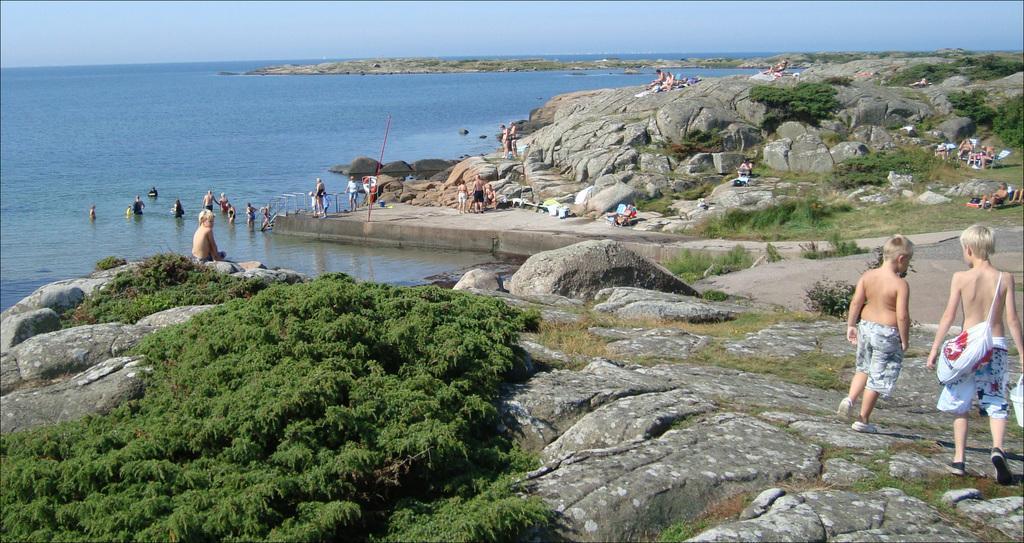Could you give a brief overview of what you see in this image? In this image we can see people and there are rocks. On the left there is a river. On the right there are chaise lounges. In the background there is sky. At the bottom there is grass and plants. 